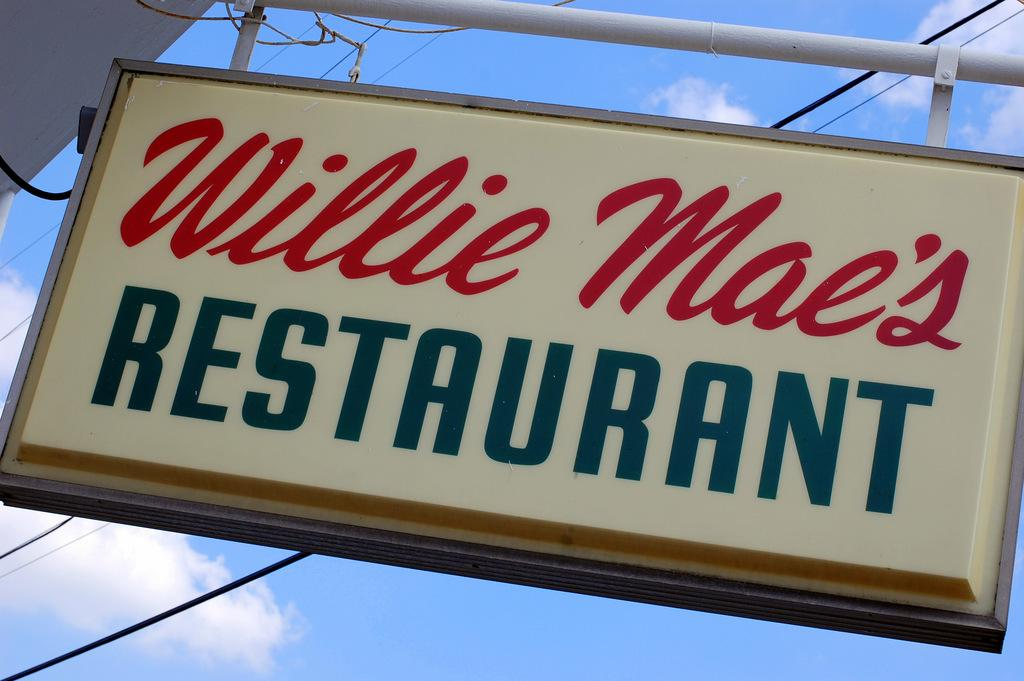<image>
Describe the image concisely. A sign for a restaurant hangs from a pole. 